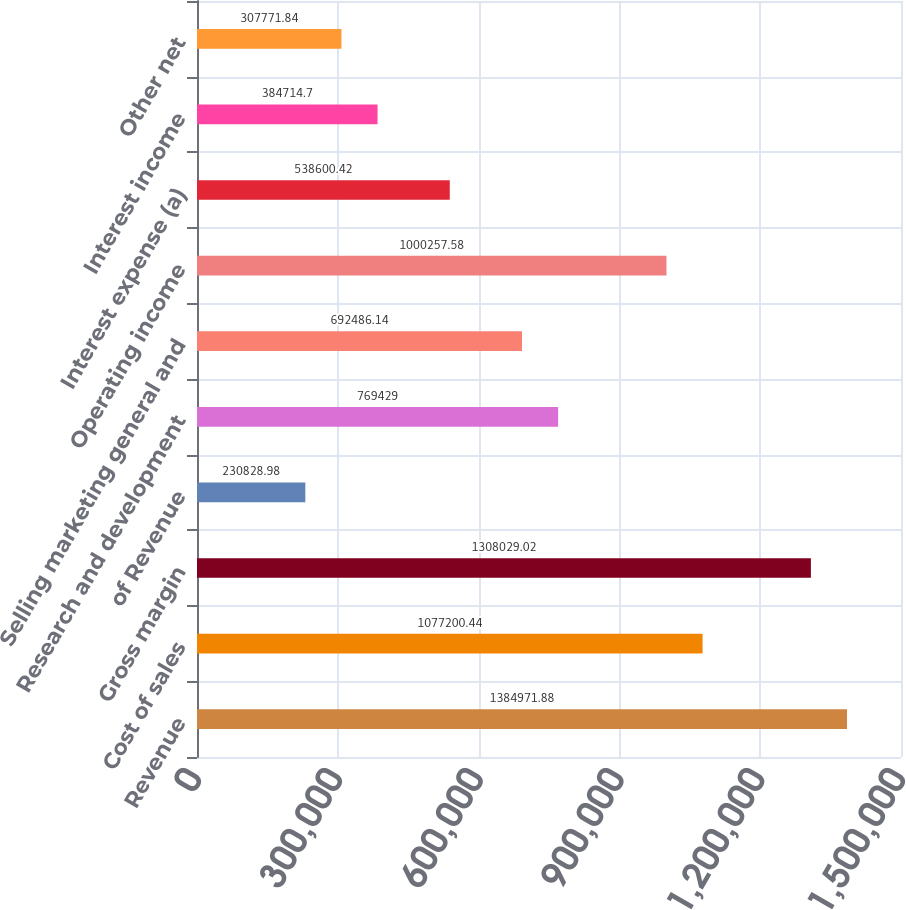<chart> <loc_0><loc_0><loc_500><loc_500><bar_chart><fcel>Revenue<fcel>Cost of sales<fcel>Gross margin<fcel>of Revenue<fcel>Research and development<fcel>Selling marketing general and<fcel>Operating income<fcel>Interest expense (a)<fcel>Interest income<fcel>Other net<nl><fcel>1.38497e+06<fcel>1.0772e+06<fcel>1.30803e+06<fcel>230829<fcel>769429<fcel>692486<fcel>1.00026e+06<fcel>538600<fcel>384715<fcel>307772<nl></chart> 